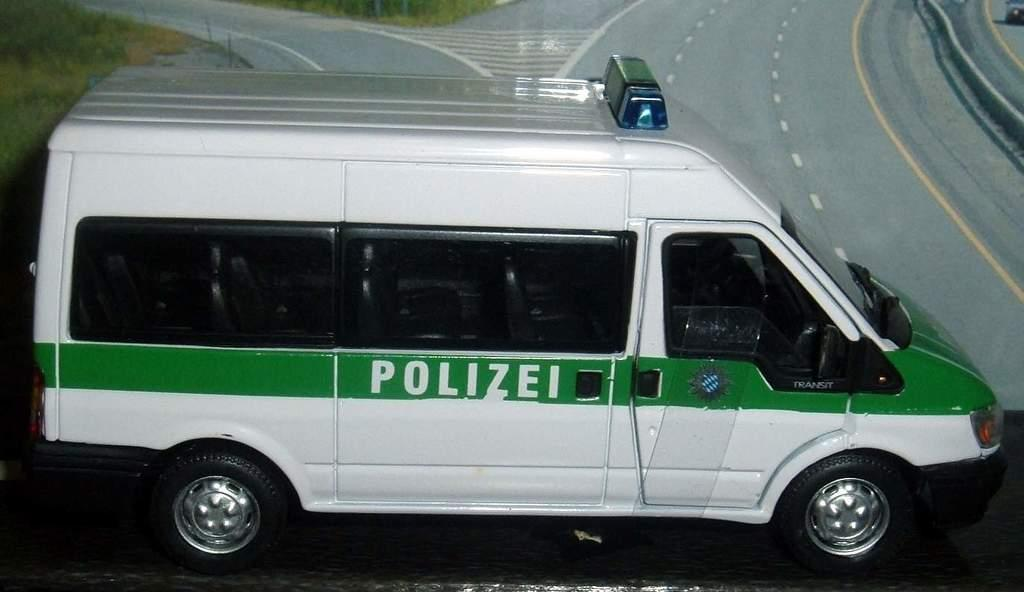<image>
Render a clear and concise summary of the photo. White and green van which says "Polizei" on the side. 